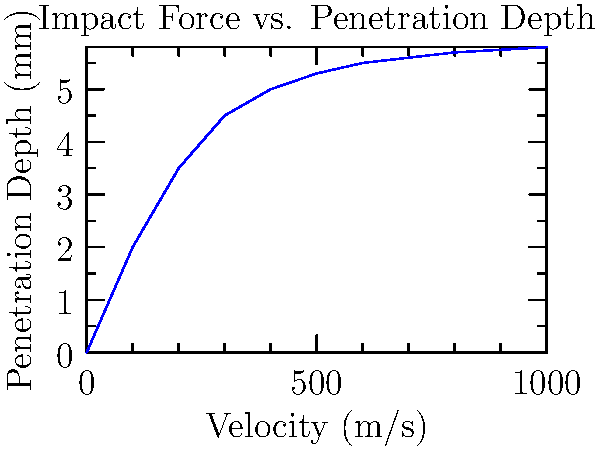Based on the graph showing the relationship between bullet velocity and penetration depth in body armor, at what approximate velocity does the penetration depth start to level off, indicating diminishing returns in armor penetration? To answer this question, we need to analyze the graph carefully:

1. The x-axis represents bullet velocity in m/s, while the y-axis shows penetration depth in mm.
2. The curve initially rises steeply, indicating that as velocity increases, penetration depth increases rapidly.
3. However, the curve starts to flatten out as it progresses, showing a decrease in the rate of penetration depth increase.
4. To find where the penetration depth starts to level off, we need to look for the point where the curve's slope begins to decrease significantly.
5. Observing the graph, we can see that around 400-500 m/s, the curve starts to flatten noticeably.
6. After this point, increases in velocity result in much smaller increases in penetration depth, indicating diminishing returns.

Therefore, the approximate velocity at which penetration depth starts to level off is around 400-500 m/s.
Answer: 400-500 m/s 